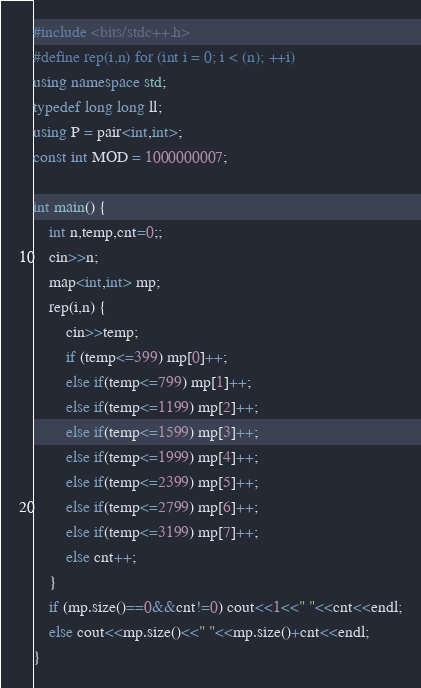<code> <loc_0><loc_0><loc_500><loc_500><_C++_>#include <bits/stdc++.h>
#define rep(i,n) for (int i = 0; i < (n); ++i)
using namespace std;
typedef long long ll;
using P = pair<int,int>;
const int MOD = 1000000007;

int main() {
    int n,temp,cnt=0;;
    cin>>n;
    map<int,int> mp;
    rep(i,n) {
        cin>>temp;
        if (temp<=399) mp[0]++;
        else if(temp<=799) mp[1]++;
        else if(temp<=1199) mp[2]++;
        else if(temp<=1599) mp[3]++;
        else if(temp<=1999) mp[4]++;
        else if(temp<=2399) mp[5]++;
        else if(temp<=2799) mp[6]++;
        else if(temp<=3199) mp[7]++;
        else cnt++; 
    }
    if (mp.size()==0&&cnt!=0) cout<<1<<" "<<cnt<<endl;
    else cout<<mp.size()<<" "<<mp.size()+cnt<<endl;
}
</code> 